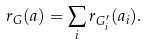<formula> <loc_0><loc_0><loc_500><loc_500>r _ { G } ( a ) = \sum _ { i } r _ { G ^ { \prime } _ { i } } ( a _ { i } ) .</formula> 